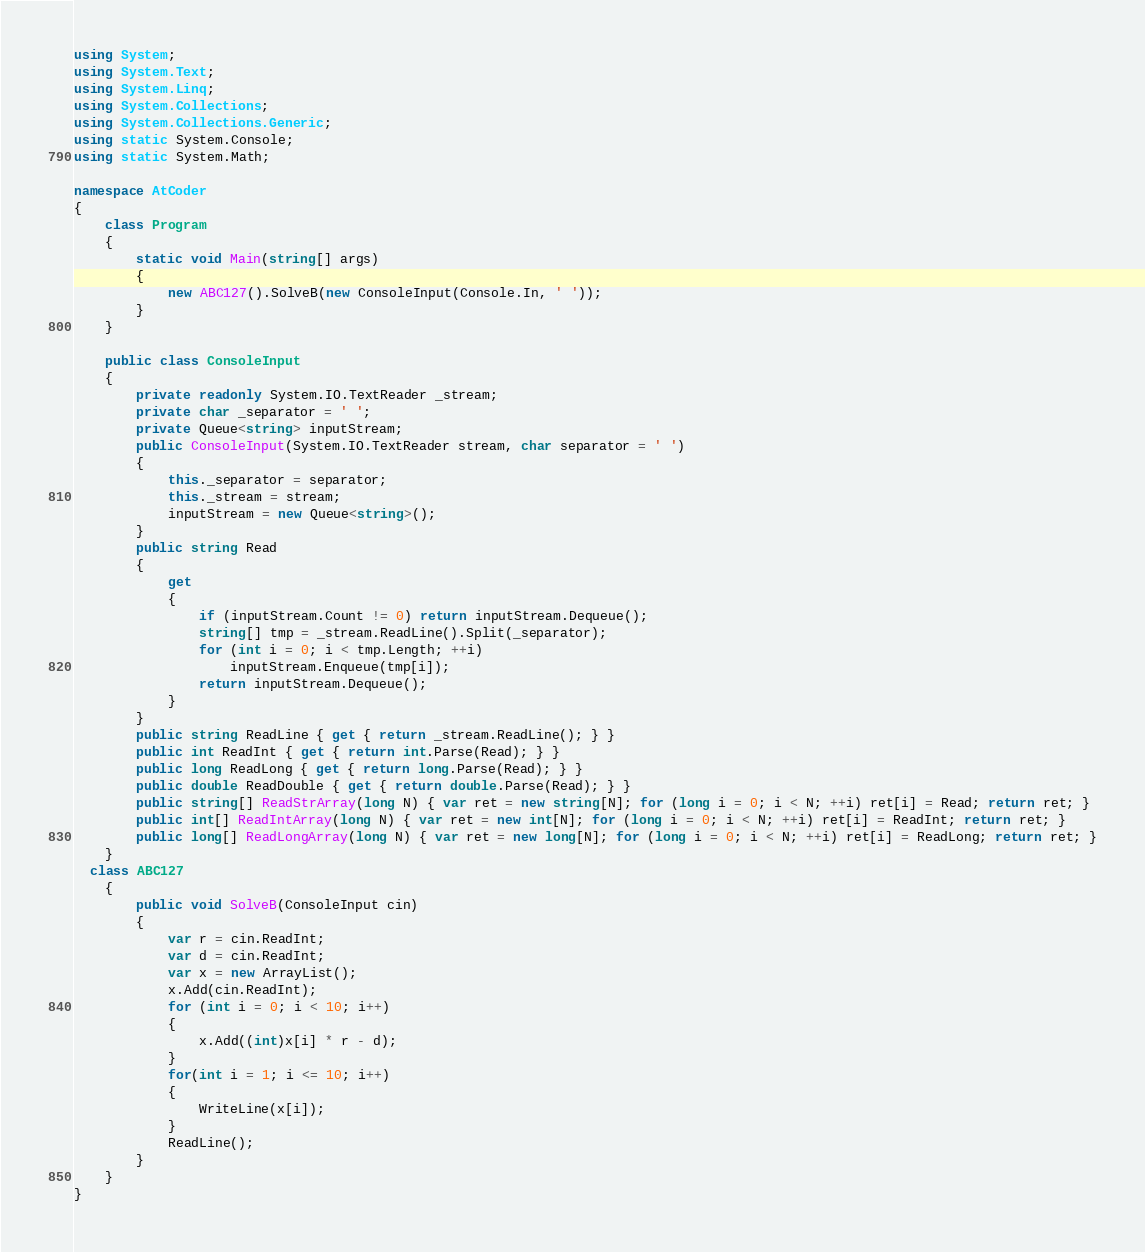Convert code to text. <code><loc_0><loc_0><loc_500><loc_500><_C#_>using System;
using System.Text;
using System.Linq;
using System.Collections;
using System.Collections.Generic;
using static System.Console;
using static System.Math;

namespace AtCoder
{
    class Program
    {
        static void Main(string[] args)
        {
            new ABC127().SolveB(new ConsoleInput(Console.In, ' '));
        }
    }

    public class ConsoleInput
    {
        private readonly System.IO.TextReader _stream;
        private char _separator = ' ';
        private Queue<string> inputStream;
        public ConsoleInput(System.IO.TextReader stream, char separator = ' ')
        {
            this._separator = separator;
            this._stream = stream;
            inputStream = new Queue<string>();
        }
        public string Read
        {
            get
            {
                if (inputStream.Count != 0) return inputStream.Dequeue();
                string[] tmp = _stream.ReadLine().Split(_separator);
                for (int i = 0; i < tmp.Length; ++i)
                    inputStream.Enqueue(tmp[i]);
                return inputStream.Dequeue();
            }
        }
        public string ReadLine { get { return _stream.ReadLine(); } }
        public int ReadInt { get { return int.Parse(Read); } }
        public long ReadLong { get { return long.Parse(Read); } }
        public double ReadDouble { get { return double.Parse(Read); } }
        public string[] ReadStrArray(long N) { var ret = new string[N]; for (long i = 0; i < N; ++i) ret[i] = Read; return ret; }
        public int[] ReadIntArray(long N) { var ret = new int[N]; for (long i = 0; i < N; ++i) ret[i] = ReadInt; return ret; }
        public long[] ReadLongArray(long N) { var ret = new long[N]; for (long i = 0; i < N; ++i) ret[i] = ReadLong; return ret; }
    }
  class ABC127
    {
    	public void SolveB(ConsoleInput cin)
        {
            var r = cin.ReadInt;
            var d = cin.ReadInt;
            var x = new ArrayList();
            x.Add(cin.ReadInt);
            for (int i = 0; i < 10; i++)
            {
                x.Add((int)x[i] * r - d);
            }
            for(int i = 1; i <= 10; i++)
            {
                WriteLine(x[i]);
            }
            ReadLine();
        }
    }
}
</code> 